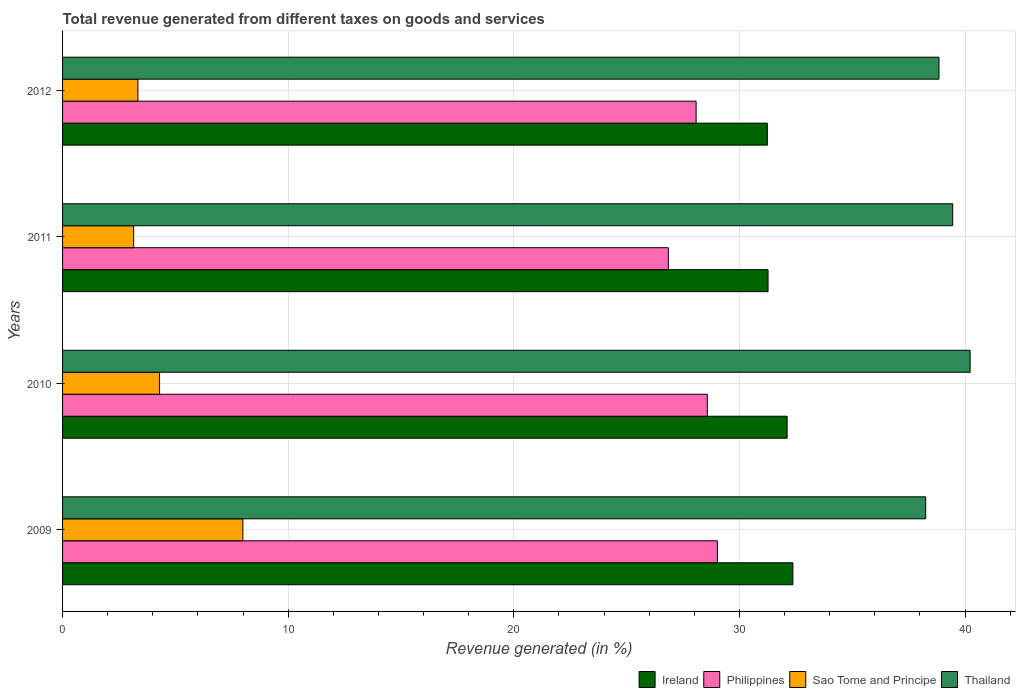Are the number of bars per tick equal to the number of legend labels?
Make the answer very short. Yes. How many bars are there on the 2nd tick from the bottom?
Give a very brief answer. 4. What is the total revenue generated in Philippines in 2012?
Provide a short and direct response. 28.08. Across all years, what is the maximum total revenue generated in Ireland?
Offer a very short reply. 32.37. Across all years, what is the minimum total revenue generated in Sao Tome and Principe?
Make the answer very short. 3.15. In which year was the total revenue generated in Philippines maximum?
Your answer should be very brief. 2009. In which year was the total revenue generated in Thailand minimum?
Provide a succinct answer. 2009. What is the total total revenue generated in Philippines in the graph?
Offer a very short reply. 112.53. What is the difference between the total revenue generated in Thailand in 2009 and that in 2010?
Your response must be concise. -1.97. What is the difference between the total revenue generated in Ireland in 2009 and the total revenue generated in Thailand in 2012?
Your answer should be very brief. -6.48. What is the average total revenue generated in Sao Tome and Principe per year?
Offer a terse response. 4.7. In the year 2010, what is the difference between the total revenue generated in Thailand and total revenue generated in Ireland?
Your response must be concise. 8.11. In how many years, is the total revenue generated in Sao Tome and Principe greater than 16 %?
Give a very brief answer. 0. What is the ratio of the total revenue generated in Philippines in 2009 to that in 2010?
Keep it short and to the point. 1.02. Is the total revenue generated in Sao Tome and Principe in 2010 less than that in 2011?
Make the answer very short. No. Is the difference between the total revenue generated in Thailand in 2011 and 2012 greater than the difference between the total revenue generated in Ireland in 2011 and 2012?
Your answer should be very brief. Yes. What is the difference between the highest and the second highest total revenue generated in Ireland?
Offer a very short reply. 0.26. What is the difference between the highest and the lowest total revenue generated in Ireland?
Your response must be concise. 1.13. What does the 4th bar from the top in 2009 represents?
Your response must be concise. Ireland. What does the 1st bar from the bottom in 2011 represents?
Offer a very short reply. Ireland. Are the values on the major ticks of X-axis written in scientific E-notation?
Offer a terse response. No. Does the graph contain any zero values?
Offer a very short reply. No. Does the graph contain grids?
Provide a short and direct response. Yes. How many legend labels are there?
Your answer should be very brief. 4. How are the legend labels stacked?
Give a very brief answer. Horizontal. What is the title of the graph?
Give a very brief answer. Total revenue generated from different taxes on goods and services. What is the label or title of the X-axis?
Offer a very short reply. Revenue generated (in %). What is the label or title of the Y-axis?
Make the answer very short. Years. What is the Revenue generated (in %) of Ireland in 2009?
Your answer should be compact. 32.37. What is the Revenue generated (in %) of Philippines in 2009?
Keep it short and to the point. 29.02. What is the Revenue generated (in %) in Sao Tome and Principe in 2009?
Give a very brief answer. 7.99. What is the Revenue generated (in %) of Thailand in 2009?
Your answer should be very brief. 38.25. What is the Revenue generated (in %) of Ireland in 2010?
Your answer should be compact. 32.11. What is the Revenue generated (in %) in Philippines in 2010?
Provide a succinct answer. 28.58. What is the Revenue generated (in %) in Sao Tome and Principe in 2010?
Provide a succinct answer. 4.3. What is the Revenue generated (in %) in Thailand in 2010?
Offer a terse response. 40.22. What is the Revenue generated (in %) in Ireland in 2011?
Ensure brevity in your answer.  31.27. What is the Revenue generated (in %) of Philippines in 2011?
Your answer should be very brief. 26.85. What is the Revenue generated (in %) of Sao Tome and Principe in 2011?
Provide a succinct answer. 3.15. What is the Revenue generated (in %) of Thailand in 2011?
Your response must be concise. 39.45. What is the Revenue generated (in %) of Ireland in 2012?
Your answer should be compact. 31.24. What is the Revenue generated (in %) of Philippines in 2012?
Offer a very short reply. 28.08. What is the Revenue generated (in %) of Sao Tome and Principe in 2012?
Your answer should be compact. 3.34. What is the Revenue generated (in %) of Thailand in 2012?
Make the answer very short. 38.84. Across all years, what is the maximum Revenue generated (in %) of Ireland?
Offer a terse response. 32.37. Across all years, what is the maximum Revenue generated (in %) of Philippines?
Provide a succinct answer. 29.02. Across all years, what is the maximum Revenue generated (in %) in Sao Tome and Principe?
Provide a short and direct response. 7.99. Across all years, what is the maximum Revenue generated (in %) in Thailand?
Make the answer very short. 40.22. Across all years, what is the minimum Revenue generated (in %) of Ireland?
Your answer should be very brief. 31.24. Across all years, what is the minimum Revenue generated (in %) of Philippines?
Offer a very short reply. 26.85. Across all years, what is the minimum Revenue generated (in %) of Sao Tome and Principe?
Ensure brevity in your answer.  3.15. Across all years, what is the minimum Revenue generated (in %) of Thailand?
Ensure brevity in your answer.  38.25. What is the total Revenue generated (in %) in Ireland in the graph?
Offer a very short reply. 126.98. What is the total Revenue generated (in %) of Philippines in the graph?
Provide a short and direct response. 112.53. What is the total Revenue generated (in %) of Sao Tome and Principe in the graph?
Give a very brief answer. 18.78. What is the total Revenue generated (in %) of Thailand in the graph?
Provide a short and direct response. 156.77. What is the difference between the Revenue generated (in %) of Ireland in 2009 and that in 2010?
Keep it short and to the point. 0.26. What is the difference between the Revenue generated (in %) of Philippines in 2009 and that in 2010?
Provide a short and direct response. 0.45. What is the difference between the Revenue generated (in %) of Sao Tome and Principe in 2009 and that in 2010?
Ensure brevity in your answer.  3.69. What is the difference between the Revenue generated (in %) of Thailand in 2009 and that in 2010?
Keep it short and to the point. -1.97. What is the difference between the Revenue generated (in %) of Ireland in 2009 and that in 2011?
Offer a very short reply. 1.1. What is the difference between the Revenue generated (in %) of Philippines in 2009 and that in 2011?
Provide a short and direct response. 2.17. What is the difference between the Revenue generated (in %) of Sao Tome and Principe in 2009 and that in 2011?
Your answer should be compact. 4.84. What is the difference between the Revenue generated (in %) in Thailand in 2009 and that in 2011?
Provide a succinct answer. -1.2. What is the difference between the Revenue generated (in %) of Ireland in 2009 and that in 2012?
Make the answer very short. 1.13. What is the difference between the Revenue generated (in %) of Philippines in 2009 and that in 2012?
Ensure brevity in your answer.  0.94. What is the difference between the Revenue generated (in %) in Sao Tome and Principe in 2009 and that in 2012?
Ensure brevity in your answer.  4.65. What is the difference between the Revenue generated (in %) in Thailand in 2009 and that in 2012?
Give a very brief answer. -0.59. What is the difference between the Revenue generated (in %) of Ireland in 2010 and that in 2011?
Your response must be concise. 0.85. What is the difference between the Revenue generated (in %) in Philippines in 2010 and that in 2011?
Your response must be concise. 1.73. What is the difference between the Revenue generated (in %) of Sao Tome and Principe in 2010 and that in 2011?
Offer a very short reply. 1.15. What is the difference between the Revenue generated (in %) in Thailand in 2010 and that in 2011?
Give a very brief answer. 0.77. What is the difference between the Revenue generated (in %) in Ireland in 2010 and that in 2012?
Your response must be concise. 0.88. What is the difference between the Revenue generated (in %) of Philippines in 2010 and that in 2012?
Your response must be concise. 0.5. What is the difference between the Revenue generated (in %) in Sao Tome and Principe in 2010 and that in 2012?
Provide a succinct answer. 0.96. What is the difference between the Revenue generated (in %) of Thailand in 2010 and that in 2012?
Offer a terse response. 1.38. What is the difference between the Revenue generated (in %) in Ireland in 2011 and that in 2012?
Ensure brevity in your answer.  0.03. What is the difference between the Revenue generated (in %) in Philippines in 2011 and that in 2012?
Your answer should be compact. -1.23. What is the difference between the Revenue generated (in %) of Sao Tome and Principe in 2011 and that in 2012?
Keep it short and to the point. -0.19. What is the difference between the Revenue generated (in %) of Thailand in 2011 and that in 2012?
Make the answer very short. 0.61. What is the difference between the Revenue generated (in %) of Ireland in 2009 and the Revenue generated (in %) of Philippines in 2010?
Ensure brevity in your answer.  3.79. What is the difference between the Revenue generated (in %) of Ireland in 2009 and the Revenue generated (in %) of Sao Tome and Principe in 2010?
Your answer should be very brief. 28.07. What is the difference between the Revenue generated (in %) of Ireland in 2009 and the Revenue generated (in %) of Thailand in 2010?
Your response must be concise. -7.86. What is the difference between the Revenue generated (in %) of Philippines in 2009 and the Revenue generated (in %) of Sao Tome and Principe in 2010?
Ensure brevity in your answer.  24.72. What is the difference between the Revenue generated (in %) in Philippines in 2009 and the Revenue generated (in %) in Thailand in 2010?
Make the answer very short. -11.2. What is the difference between the Revenue generated (in %) of Sao Tome and Principe in 2009 and the Revenue generated (in %) of Thailand in 2010?
Ensure brevity in your answer.  -32.23. What is the difference between the Revenue generated (in %) of Ireland in 2009 and the Revenue generated (in %) of Philippines in 2011?
Your answer should be very brief. 5.52. What is the difference between the Revenue generated (in %) of Ireland in 2009 and the Revenue generated (in %) of Sao Tome and Principe in 2011?
Ensure brevity in your answer.  29.22. What is the difference between the Revenue generated (in %) of Ireland in 2009 and the Revenue generated (in %) of Thailand in 2011?
Provide a succinct answer. -7.08. What is the difference between the Revenue generated (in %) in Philippines in 2009 and the Revenue generated (in %) in Sao Tome and Principe in 2011?
Offer a terse response. 25.87. What is the difference between the Revenue generated (in %) of Philippines in 2009 and the Revenue generated (in %) of Thailand in 2011?
Your response must be concise. -10.43. What is the difference between the Revenue generated (in %) of Sao Tome and Principe in 2009 and the Revenue generated (in %) of Thailand in 2011?
Ensure brevity in your answer.  -31.46. What is the difference between the Revenue generated (in %) of Ireland in 2009 and the Revenue generated (in %) of Philippines in 2012?
Your answer should be very brief. 4.29. What is the difference between the Revenue generated (in %) of Ireland in 2009 and the Revenue generated (in %) of Sao Tome and Principe in 2012?
Offer a terse response. 29.03. What is the difference between the Revenue generated (in %) in Ireland in 2009 and the Revenue generated (in %) in Thailand in 2012?
Keep it short and to the point. -6.48. What is the difference between the Revenue generated (in %) of Philippines in 2009 and the Revenue generated (in %) of Sao Tome and Principe in 2012?
Give a very brief answer. 25.68. What is the difference between the Revenue generated (in %) of Philippines in 2009 and the Revenue generated (in %) of Thailand in 2012?
Offer a very short reply. -9.82. What is the difference between the Revenue generated (in %) in Sao Tome and Principe in 2009 and the Revenue generated (in %) in Thailand in 2012?
Make the answer very short. -30.85. What is the difference between the Revenue generated (in %) in Ireland in 2010 and the Revenue generated (in %) in Philippines in 2011?
Your response must be concise. 5.26. What is the difference between the Revenue generated (in %) of Ireland in 2010 and the Revenue generated (in %) of Sao Tome and Principe in 2011?
Provide a short and direct response. 28.96. What is the difference between the Revenue generated (in %) of Ireland in 2010 and the Revenue generated (in %) of Thailand in 2011?
Offer a very short reply. -7.34. What is the difference between the Revenue generated (in %) in Philippines in 2010 and the Revenue generated (in %) in Sao Tome and Principe in 2011?
Offer a very short reply. 25.42. What is the difference between the Revenue generated (in %) in Philippines in 2010 and the Revenue generated (in %) in Thailand in 2011?
Offer a terse response. -10.88. What is the difference between the Revenue generated (in %) of Sao Tome and Principe in 2010 and the Revenue generated (in %) of Thailand in 2011?
Your response must be concise. -35.15. What is the difference between the Revenue generated (in %) of Ireland in 2010 and the Revenue generated (in %) of Philippines in 2012?
Give a very brief answer. 4.03. What is the difference between the Revenue generated (in %) in Ireland in 2010 and the Revenue generated (in %) in Sao Tome and Principe in 2012?
Offer a terse response. 28.77. What is the difference between the Revenue generated (in %) of Ireland in 2010 and the Revenue generated (in %) of Thailand in 2012?
Ensure brevity in your answer.  -6.73. What is the difference between the Revenue generated (in %) of Philippines in 2010 and the Revenue generated (in %) of Sao Tome and Principe in 2012?
Make the answer very short. 25.24. What is the difference between the Revenue generated (in %) of Philippines in 2010 and the Revenue generated (in %) of Thailand in 2012?
Your answer should be very brief. -10.27. What is the difference between the Revenue generated (in %) of Sao Tome and Principe in 2010 and the Revenue generated (in %) of Thailand in 2012?
Offer a very short reply. -34.54. What is the difference between the Revenue generated (in %) in Ireland in 2011 and the Revenue generated (in %) in Philippines in 2012?
Your response must be concise. 3.19. What is the difference between the Revenue generated (in %) in Ireland in 2011 and the Revenue generated (in %) in Sao Tome and Principe in 2012?
Your answer should be compact. 27.93. What is the difference between the Revenue generated (in %) of Ireland in 2011 and the Revenue generated (in %) of Thailand in 2012?
Your answer should be compact. -7.58. What is the difference between the Revenue generated (in %) of Philippines in 2011 and the Revenue generated (in %) of Sao Tome and Principe in 2012?
Offer a very short reply. 23.51. What is the difference between the Revenue generated (in %) in Philippines in 2011 and the Revenue generated (in %) in Thailand in 2012?
Provide a short and direct response. -11.99. What is the difference between the Revenue generated (in %) of Sao Tome and Principe in 2011 and the Revenue generated (in %) of Thailand in 2012?
Make the answer very short. -35.69. What is the average Revenue generated (in %) in Ireland per year?
Provide a succinct answer. 31.75. What is the average Revenue generated (in %) of Philippines per year?
Keep it short and to the point. 28.13. What is the average Revenue generated (in %) of Sao Tome and Principe per year?
Offer a very short reply. 4.7. What is the average Revenue generated (in %) of Thailand per year?
Your response must be concise. 39.19. In the year 2009, what is the difference between the Revenue generated (in %) in Ireland and Revenue generated (in %) in Philippines?
Make the answer very short. 3.35. In the year 2009, what is the difference between the Revenue generated (in %) in Ireland and Revenue generated (in %) in Sao Tome and Principe?
Give a very brief answer. 24.38. In the year 2009, what is the difference between the Revenue generated (in %) in Ireland and Revenue generated (in %) in Thailand?
Your answer should be compact. -5.89. In the year 2009, what is the difference between the Revenue generated (in %) of Philippines and Revenue generated (in %) of Sao Tome and Principe?
Give a very brief answer. 21.03. In the year 2009, what is the difference between the Revenue generated (in %) in Philippines and Revenue generated (in %) in Thailand?
Ensure brevity in your answer.  -9.23. In the year 2009, what is the difference between the Revenue generated (in %) of Sao Tome and Principe and Revenue generated (in %) of Thailand?
Give a very brief answer. -30.26. In the year 2010, what is the difference between the Revenue generated (in %) of Ireland and Revenue generated (in %) of Philippines?
Give a very brief answer. 3.54. In the year 2010, what is the difference between the Revenue generated (in %) of Ireland and Revenue generated (in %) of Sao Tome and Principe?
Offer a very short reply. 27.81. In the year 2010, what is the difference between the Revenue generated (in %) of Ireland and Revenue generated (in %) of Thailand?
Ensure brevity in your answer.  -8.11. In the year 2010, what is the difference between the Revenue generated (in %) of Philippines and Revenue generated (in %) of Sao Tome and Principe?
Offer a terse response. 24.28. In the year 2010, what is the difference between the Revenue generated (in %) of Philippines and Revenue generated (in %) of Thailand?
Ensure brevity in your answer.  -11.65. In the year 2010, what is the difference between the Revenue generated (in %) in Sao Tome and Principe and Revenue generated (in %) in Thailand?
Offer a terse response. -35.92. In the year 2011, what is the difference between the Revenue generated (in %) of Ireland and Revenue generated (in %) of Philippines?
Provide a short and direct response. 4.42. In the year 2011, what is the difference between the Revenue generated (in %) in Ireland and Revenue generated (in %) in Sao Tome and Principe?
Give a very brief answer. 28.12. In the year 2011, what is the difference between the Revenue generated (in %) in Ireland and Revenue generated (in %) in Thailand?
Ensure brevity in your answer.  -8.18. In the year 2011, what is the difference between the Revenue generated (in %) in Philippines and Revenue generated (in %) in Sao Tome and Principe?
Offer a very short reply. 23.7. In the year 2011, what is the difference between the Revenue generated (in %) of Philippines and Revenue generated (in %) of Thailand?
Provide a succinct answer. -12.6. In the year 2011, what is the difference between the Revenue generated (in %) of Sao Tome and Principe and Revenue generated (in %) of Thailand?
Your answer should be compact. -36.3. In the year 2012, what is the difference between the Revenue generated (in %) of Ireland and Revenue generated (in %) of Philippines?
Make the answer very short. 3.16. In the year 2012, what is the difference between the Revenue generated (in %) in Ireland and Revenue generated (in %) in Sao Tome and Principe?
Your answer should be compact. 27.9. In the year 2012, what is the difference between the Revenue generated (in %) in Ireland and Revenue generated (in %) in Thailand?
Your response must be concise. -7.61. In the year 2012, what is the difference between the Revenue generated (in %) in Philippines and Revenue generated (in %) in Sao Tome and Principe?
Your answer should be compact. 24.74. In the year 2012, what is the difference between the Revenue generated (in %) of Philippines and Revenue generated (in %) of Thailand?
Keep it short and to the point. -10.76. In the year 2012, what is the difference between the Revenue generated (in %) in Sao Tome and Principe and Revenue generated (in %) in Thailand?
Keep it short and to the point. -35.5. What is the ratio of the Revenue generated (in %) of Ireland in 2009 to that in 2010?
Give a very brief answer. 1.01. What is the ratio of the Revenue generated (in %) in Philippines in 2009 to that in 2010?
Offer a terse response. 1.02. What is the ratio of the Revenue generated (in %) of Sao Tome and Principe in 2009 to that in 2010?
Your answer should be very brief. 1.86. What is the ratio of the Revenue generated (in %) in Thailand in 2009 to that in 2010?
Offer a very short reply. 0.95. What is the ratio of the Revenue generated (in %) of Ireland in 2009 to that in 2011?
Your response must be concise. 1.04. What is the ratio of the Revenue generated (in %) of Philippines in 2009 to that in 2011?
Make the answer very short. 1.08. What is the ratio of the Revenue generated (in %) in Sao Tome and Principe in 2009 to that in 2011?
Ensure brevity in your answer.  2.54. What is the ratio of the Revenue generated (in %) of Thailand in 2009 to that in 2011?
Make the answer very short. 0.97. What is the ratio of the Revenue generated (in %) in Ireland in 2009 to that in 2012?
Your response must be concise. 1.04. What is the ratio of the Revenue generated (in %) in Philippines in 2009 to that in 2012?
Provide a short and direct response. 1.03. What is the ratio of the Revenue generated (in %) in Sao Tome and Principe in 2009 to that in 2012?
Your answer should be compact. 2.39. What is the ratio of the Revenue generated (in %) of Philippines in 2010 to that in 2011?
Ensure brevity in your answer.  1.06. What is the ratio of the Revenue generated (in %) of Sao Tome and Principe in 2010 to that in 2011?
Your response must be concise. 1.36. What is the ratio of the Revenue generated (in %) in Thailand in 2010 to that in 2011?
Your answer should be compact. 1.02. What is the ratio of the Revenue generated (in %) of Ireland in 2010 to that in 2012?
Your response must be concise. 1.03. What is the ratio of the Revenue generated (in %) of Philippines in 2010 to that in 2012?
Keep it short and to the point. 1.02. What is the ratio of the Revenue generated (in %) in Sao Tome and Principe in 2010 to that in 2012?
Your response must be concise. 1.29. What is the ratio of the Revenue generated (in %) in Thailand in 2010 to that in 2012?
Ensure brevity in your answer.  1.04. What is the ratio of the Revenue generated (in %) in Ireland in 2011 to that in 2012?
Your answer should be compact. 1. What is the ratio of the Revenue generated (in %) of Philippines in 2011 to that in 2012?
Your response must be concise. 0.96. What is the ratio of the Revenue generated (in %) in Sao Tome and Principe in 2011 to that in 2012?
Your answer should be very brief. 0.94. What is the ratio of the Revenue generated (in %) in Thailand in 2011 to that in 2012?
Your response must be concise. 1.02. What is the difference between the highest and the second highest Revenue generated (in %) in Ireland?
Your answer should be very brief. 0.26. What is the difference between the highest and the second highest Revenue generated (in %) of Philippines?
Make the answer very short. 0.45. What is the difference between the highest and the second highest Revenue generated (in %) in Sao Tome and Principe?
Offer a terse response. 3.69. What is the difference between the highest and the second highest Revenue generated (in %) in Thailand?
Keep it short and to the point. 0.77. What is the difference between the highest and the lowest Revenue generated (in %) in Ireland?
Your answer should be compact. 1.13. What is the difference between the highest and the lowest Revenue generated (in %) of Philippines?
Ensure brevity in your answer.  2.17. What is the difference between the highest and the lowest Revenue generated (in %) of Sao Tome and Principe?
Keep it short and to the point. 4.84. What is the difference between the highest and the lowest Revenue generated (in %) in Thailand?
Your answer should be compact. 1.97. 